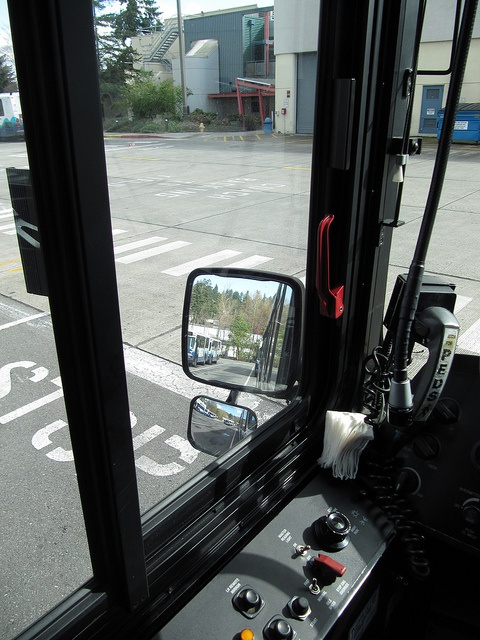Describe the objects in this image and their specific colors. I can see bus in lightblue, lightgray, gray, and teal tones, car in lightblue, blue, gray, and darkblue tones, bus in lightblue, gray, lightgray, and darkgray tones, and car in lightblue, blue, black, and teal tones in this image. 